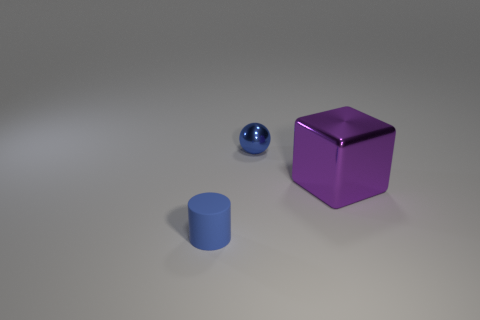Add 2 big purple objects. How many objects exist? 5 Subtract all cylinders. How many objects are left? 2 Add 1 cylinders. How many cylinders exist? 2 Subtract 1 purple blocks. How many objects are left? 2 Subtract all large blocks. Subtract all rubber cylinders. How many objects are left? 1 Add 1 tiny rubber things. How many tiny rubber things are left? 2 